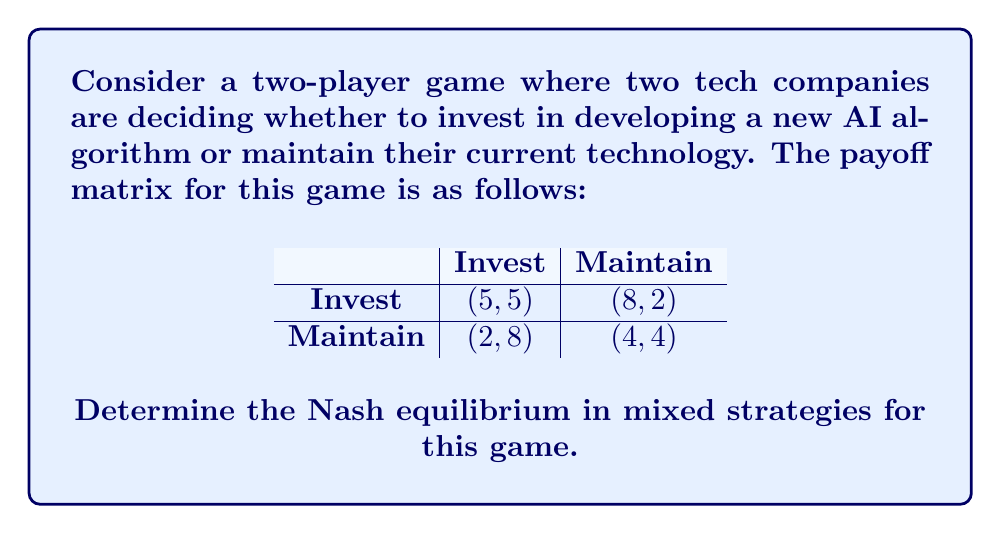Give your solution to this math problem. To find the Nash equilibrium in mixed strategies, we need to follow these steps:

1) Let $p$ be the probability that Player 1 chooses to Invest, and $q$ be the probability that Player 2 chooses to Invest.

2) For a mixed strategy to be optimal, the expected payoff for each pure strategy must be equal. We can set up equations for each player:

For Player 1:
$5q + 8(1-q) = 2q + 4(1-q)$

For Player 2:
$5p + 2(1-p) = 8p + 4(1-p)$

3) Solve these equations:

For Player 1:
$5q + 8 - 8q = 2q + 4 - 4q$
$8 - 3q = 4 + 2q$
$4 = 5q$
$q = \frac{4}{5} = 0.8$

For Player 2:
$5p + 2 - 2p = 8p + 4 - 4p$
$2 + 3p = 4 + 4p$
$-2 = p$
$p = \frac{2}{3} \approx 0.67$

4) Therefore, in the mixed strategy Nash equilibrium:
   - Player 1 invests with probability $\frac{2}{3}$ and maintains with probability $\frac{1}{3}$
   - Player 2 invests with probability $\frac{4}{5}$ and maintains with probability $\frac{1}{5}$

5) We can verify that these strategies indeed form a Nash equilibrium by checking that neither player can improve their payoff by unilaterally changing their strategy.
Answer: The Nash equilibrium in mixed strategies is:
Player 1: $(\frac{2}{3}, \frac{1}{3})$
Player 2: $(\frac{4}{5}, \frac{1}{5})$
where the first number in each pair represents the probability of investing, and the second number represents the probability of maintaining. 